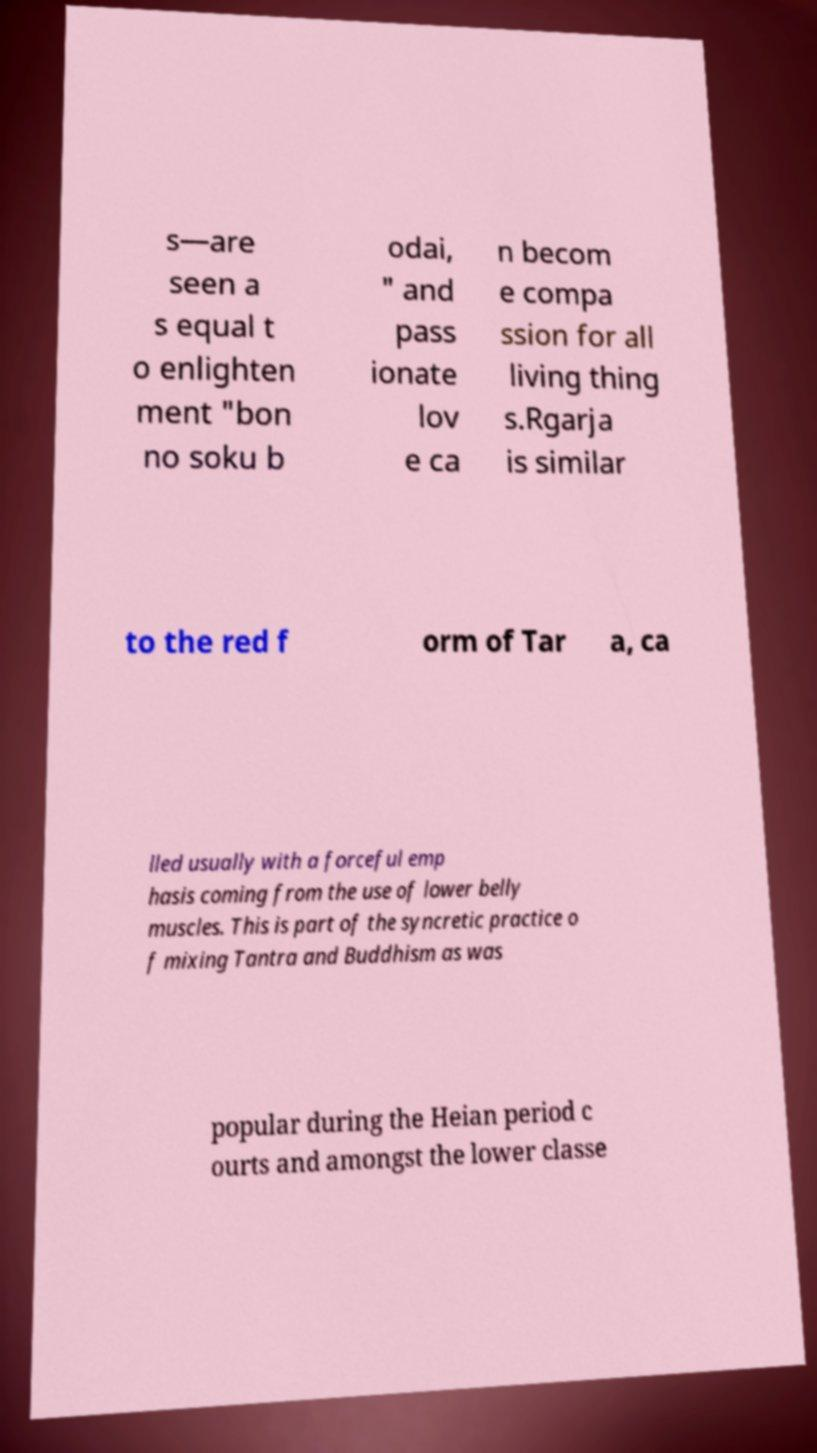Could you assist in decoding the text presented in this image and type it out clearly? s—are seen a s equal t o enlighten ment "bon no soku b odai, " and pass ionate lov e ca n becom e compa ssion for all living thing s.Rgarja is similar to the red f orm of Tar a, ca lled usually with a forceful emp hasis coming from the use of lower belly muscles. This is part of the syncretic practice o f mixing Tantra and Buddhism as was popular during the Heian period c ourts and amongst the lower classe 